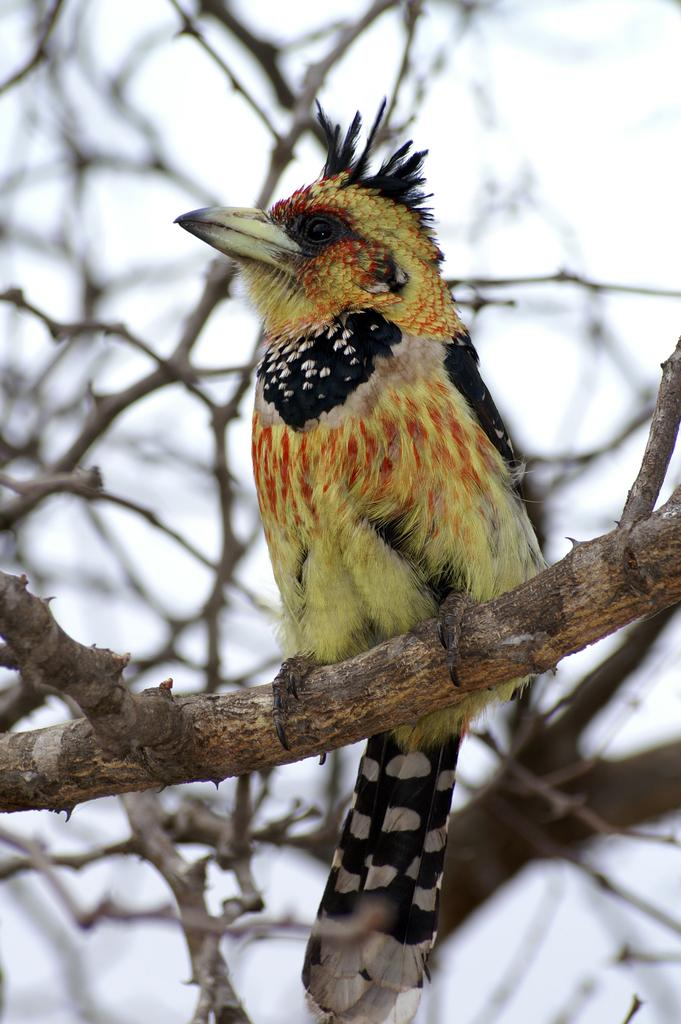What animal can be seen in the picture? There is a bird in the picture. What is the bird standing on? The bird is standing on a dried tree. What colors can be observed on the bird? The bird has a yellow color, as well as some black and white coloring. What type of writing instrument is the bird using in the picture? There is no writing instrument present in the image, as the bird is simply standing on a dried tree. 